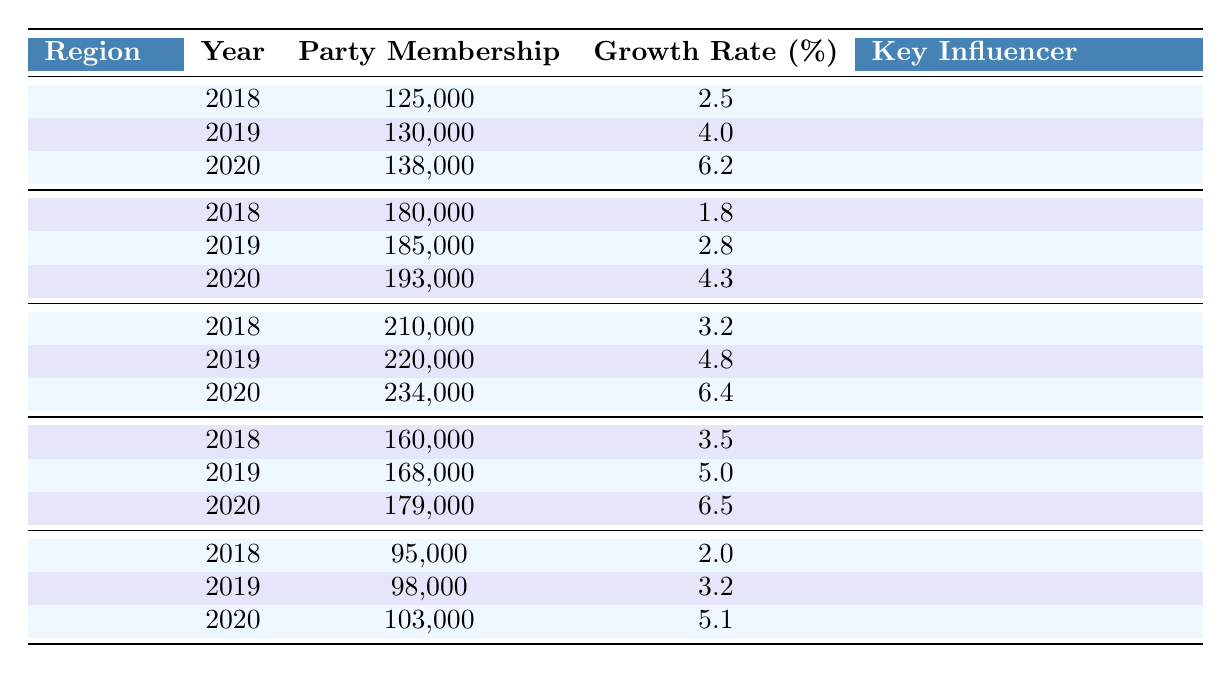What was the party membership in the South in 2020? The table shows that in the South region, the party membership for the year 2020 is listed as 234,000.
Answer: 234,000 Which region had the highest growth rate in 2019? The growth rates for 2019 are as follows: Midwest 4.0%, Northeast 2.8%, South 4.8%, West 5.0%, and Southwest 3.2%. The South had the highest growth rate of 4.8% in that year.
Answer: South What is the average party membership in the Southwest across the three years? The membership values for the Southwest are 95,000 (2018), 98,000 (2019), and 103,000 (2020). Summing these gives 95,000 + 98,000 + 103,000 = 296,000, and dividing by 3 gives an average of 296,000 / 3 = 98,666.67.
Answer: 98,666.67 In which year did the Midwest experience the greatest percentage growth in party membership? Looking at the growth rates for the Midwest: 2.5% (2018), 4.0% (2019), and 6.2% (2020), the greatest growth rate was 6.2% in 2020.
Answer: 2020 Was the influencer for the Northeast region the same throughout the years? The table indicates that the key influencer for the Northeast across all years (2018, 2019, and 2020) is consistently Senator Elizabeth Warren, confirming that it was the same.
Answer: Yes What was the total party membership increase in the South from 2018 to 2020? The party membership in the South is 210,000 in 2018, and it increased to 234,000 in 2020. The increase is 234,000 - 210,000 = 24,000.
Answer: 24,000 Which region's growth rate showed the most significant improvement from 2018 to 2020? By calculating growth rates for each region, in the South, it grew from 3.2% (2018) to 6.4% (2020) which is a 3.2% increase. In the Midwest, it increased from 2.5% to 6.2%, a 3.7% increase, the largest improvement overall.
Answer: Midwest What is the total membership across all regions in 2019? The memberships for 2019 are: Midwest 130,000, Northeast 185,000, South 220,000, West 168,000, and Southwest 98,000. Adding these values gives 130,000 + 185,000 + 220,000 + 168,000 + 98,000 = 801,000.
Answer: 801,000 For the West region, what was the membership trend from 2018 to 2020? The West region membership increased from 160,000 in 2018 to 179,000 in 2020. Specifically, it grew to 168,000 in 2019. So, the trend is increasing each year.
Answer: Increasing Which key influencer had the least amount of total party membership in their region for 2018? In 2018, the Southwest had the least amount of party membership at 95,000, influenced by Senator Mark Kelly.
Answer: Senator Mark Kelly 